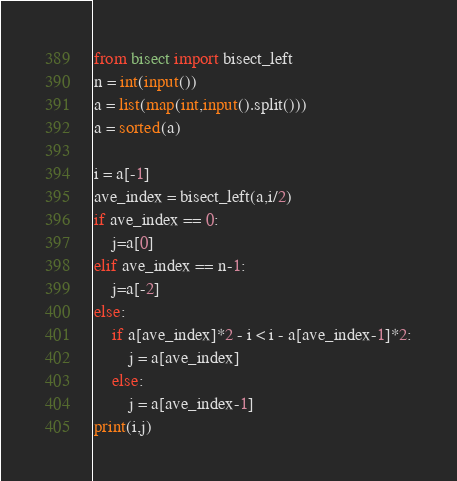<code> <loc_0><loc_0><loc_500><loc_500><_Python_>from bisect import bisect_left
n = int(input())
a = list(map(int,input().split()))
a = sorted(a)

i = a[-1]
ave_index = bisect_left(a,i/2)
if ave_index == 0:
    j=a[0]
elif ave_index == n-1:
    j=a[-2]
else:
    if a[ave_index]*2 - i < i - a[ave_index-1]*2:
        j = a[ave_index]
    else:
        j = a[ave_index-1]
print(i,j)</code> 